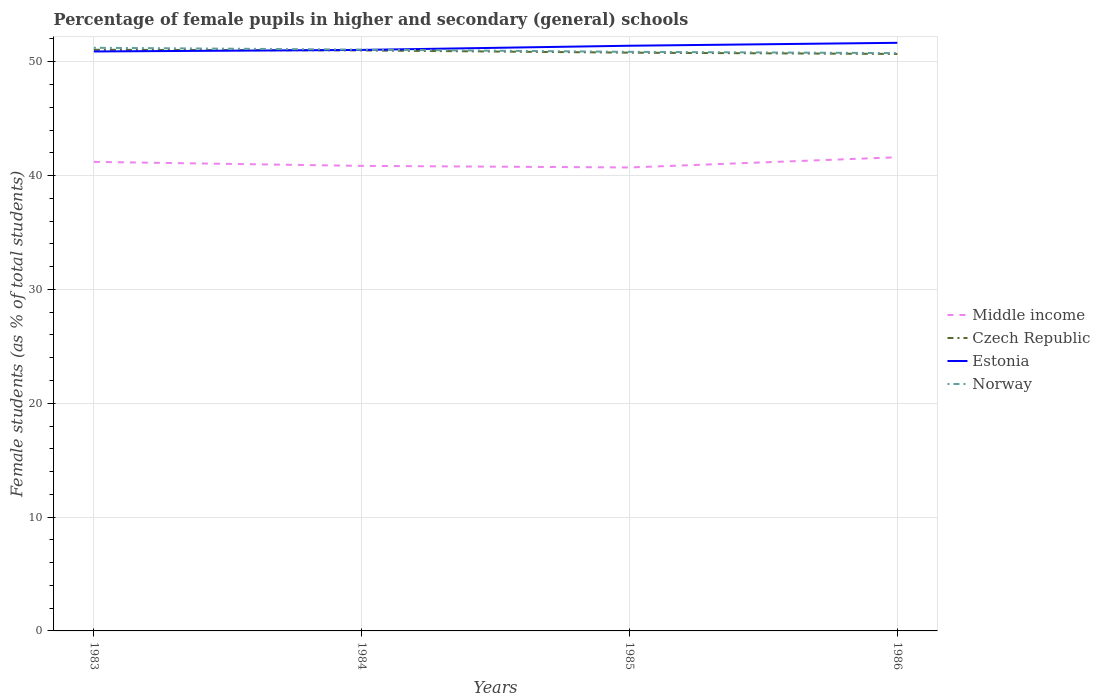How many different coloured lines are there?
Your answer should be compact. 4. Is the number of lines equal to the number of legend labels?
Ensure brevity in your answer.  Yes. Across all years, what is the maximum percentage of female pupils in higher and secondary schools in Estonia?
Ensure brevity in your answer.  50.9. In which year was the percentage of female pupils in higher and secondary schools in Estonia maximum?
Offer a very short reply. 1983. What is the total percentage of female pupils in higher and secondary schools in Norway in the graph?
Make the answer very short. 0.47. What is the difference between the highest and the second highest percentage of female pupils in higher and secondary schools in Norway?
Your answer should be very brief. 0.47. What is the difference between the highest and the lowest percentage of female pupils in higher and secondary schools in Norway?
Keep it short and to the point. 2. Is the percentage of female pupils in higher and secondary schools in Estonia strictly greater than the percentage of female pupils in higher and secondary schools in Norway over the years?
Offer a terse response. No. What is the difference between two consecutive major ticks on the Y-axis?
Make the answer very short. 10. Does the graph contain any zero values?
Your answer should be compact. No. Does the graph contain grids?
Give a very brief answer. Yes. What is the title of the graph?
Your answer should be compact. Percentage of female pupils in higher and secondary (general) schools. Does "Mongolia" appear as one of the legend labels in the graph?
Ensure brevity in your answer.  No. What is the label or title of the Y-axis?
Give a very brief answer. Female students (as % of total students). What is the Female students (as % of total students) in Middle income in 1983?
Make the answer very short. 41.2. What is the Female students (as % of total students) in Czech Republic in 1983?
Make the answer very short. 51.05. What is the Female students (as % of total students) in Estonia in 1983?
Make the answer very short. 50.9. What is the Female students (as % of total students) in Norway in 1983?
Provide a short and direct response. 51.23. What is the Female students (as % of total students) of Middle income in 1984?
Provide a short and direct response. 40.85. What is the Female students (as % of total students) in Czech Republic in 1984?
Offer a very short reply. 51. What is the Female students (as % of total students) of Estonia in 1984?
Give a very brief answer. 51.04. What is the Female students (as % of total students) of Norway in 1984?
Provide a short and direct response. 51.07. What is the Female students (as % of total students) of Middle income in 1985?
Keep it short and to the point. 40.71. What is the Female students (as % of total students) in Czech Republic in 1985?
Your response must be concise. 50.8. What is the Female students (as % of total students) in Estonia in 1985?
Offer a terse response. 51.41. What is the Female students (as % of total students) in Norway in 1985?
Provide a short and direct response. 50.87. What is the Female students (as % of total students) of Middle income in 1986?
Make the answer very short. 41.61. What is the Female students (as % of total students) of Czech Republic in 1986?
Your answer should be very brief. 50.69. What is the Female students (as % of total students) in Estonia in 1986?
Your answer should be very brief. 51.67. What is the Female students (as % of total students) in Norway in 1986?
Your answer should be compact. 50.76. Across all years, what is the maximum Female students (as % of total students) in Middle income?
Ensure brevity in your answer.  41.61. Across all years, what is the maximum Female students (as % of total students) of Czech Republic?
Offer a very short reply. 51.05. Across all years, what is the maximum Female students (as % of total students) of Estonia?
Your answer should be very brief. 51.67. Across all years, what is the maximum Female students (as % of total students) of Norway?
Give a very brief answer. 51.23. Across all years, what is the minimum Female students (as % of total students) of Middle income?
Offer a very short reply. 40.71. Across all years, what is the minimum Female students (as % of total students) in Czech Republic?
Provide a short and direct response. 50.69. Across all years, what is the minimum Female students (as % of total students) of Estonia?
Offer a terse response. 50.9. Across all years, what is the minimum Female students (as % of total students) in Norway?
Offer a terse response. 50.76. What is the total Female students (as % of total students) in Middle income in the graph?
Keep it short and to the point. 164.38. What is the total Female students (as % of total students) in Czech Republic in the graph?
Provide a succinct answer. 203.53. What is the total Female students (as % of total students) in Estonia in the graph?
Your response must be concise. 205.02. What is the total Female students (as % of total students) in Norway in the graph?
Your answer should be compact. 203.93. What is the difference between the Female students (as % of total students) of Middle income in 1983 and that in 1984?
Your response must be concise. 0.35. What is the difference between the Female students (as % of total students) in Czech Republic in 1983 and that in 1984?
Ensure brevity in your answer.  0.06. What is the difference between the Female students (as % of total students) of Estonia in 1983 and that in 1984?
Offer a very short reply. -0.14. What is the difference between the Female students (as % of total students) in Norway in 1983 and that in 1984?
Offer a terse response. 0.16. What is the difference between the Female students (as % of total students) of Middle income in 1983 and that in 1985?
Offer a very short reply. 0.49. What is the difference between the Female students (as % of total students) in Czech Republic in 1983 and that in 1985?
Your answer should be very brief. 0.25. What is the difference between the Female students (as % of total students) of Estonia in 1983 and that in 1985?
Keep it short and to the point. -0.5. What is the difference between the Female students (as % of total students) in Norway in 1983 and that in 1985?
Provide a short and direct response. 0.36. What is the difference between the Female students (as % of total students) of Middle income in 1983 and that in 1986?
Your response must be concise. -0.41. What is the difference between the Female students (as % of total students) in Czech Republic in 1983 and that in 1986?
Provide a short and direct response. 0.37. What is the difference between the Female students (as % of total students) of Estonia in 1983 and that in 1986?
Offer a terse response. -0.76. What is the difference between the Female students (as % of total students) of Norway in 1983 and that in 1986?
Your answer should be compact. 0.47. What is the difference between the Female students (as % of total students) in Middle income in 1984 and that in 1985?
Offer a terse response. 0.14. What is the difference between the Female students (as % of total students) of Czech Republic in 1984 and that in 1985?
Give a very brief answer. 0.2. What is the difference between the Female students (as % of total students) of Estonia in 1984 and that in 1985?
Your answer should be very brief. -0.37. What is the difference between the Female students (as % of total students) of Norway in 1984 and that in 1985?
Give a very brief answer. 0.2. What is the difference between the Female students (as % of total students) in Middle income in 1984 and that in 1986?
Offer a very short reply. -0.76. What is the difference between the Female students (as % of total students) in Czech Republic in 1984 and that in 1986?
Your response must be concise. 0.31. What is the difference between the Female students (as % of total students) of Estonia in 1984 and that in 1986?
Keep it short and to the point. -0.62. What is the difference between the Female students (as % of total students) of Norway in 1984 and that in 1986?
Provide a short and direct response. 0.31. What is the difference between the Female students (as % of total students) in Middle income in 1985 and that in 1986?
Provide a short and direct response. -0.9. What is the difference between the Female students (as % of total students) of Czech Republic in 1985 and that in 1986?
Provide a short and direct response. 0.11. What is the difference between the Female students (as % of total students) of Estonia in 1985 and that in 1986?
Offer a very short reply. -0.26. What is the difference between the Female students (as % of total students) in Norway in 1985 and that in 1986?
Give a very brief answer. 0.11. What is the difference between the Female students (as % of total students) in Middle income in 1983 and the Female students (as % of total students) in Czech Republic in 1984?
Keep it short and to the point. -9.79. What is the difference between the Female students (as % of total students) of Middle income in 1983 and the Female students (as % of total students) of Estonia in 1984?
Ensure brevity in your answer.  -9.84. What is the difference between the Female students (as % of total students) of Middle income in 1983 and the Female students (as % of total students) of Norway in 1984?
Provide a succinct answer. -9.86. What is the difference between the Female students (as % of total students) in Czech Republic in 1983 and the Female students (as % of total students) in Estonia in 1984?
Your answer should be compact. 0.01. What is the difference between the Female students (as % of total students) in Czech Republic in 1983 and the Female students (as % of total students) in Norway in 1984?
Your answer should be compact. -0.02. What is the difference between the Female students (as % of total students) of Estonia in 1983 and the Female students (as % of total students) of Norway in 1984?
Offer a very short reply. -0.16. What is the difference between the Female students (as % of total students) of Middle income in 1983 and the Female students (as % of total students) of Czech Republic in 1985?
Provide a succinct answer. -9.59. What is the difference between the Female students (as % of total students) in Middle income in 1983 and the Female students (as % of total students) in Estonia in 1985?
Keep it short and to the point. -10.2. What is the difference between the Female students (as % of total students) of Middle income in 1983 and the Female students (as % of total students) of Norway in 1985?
Make the answer very short. -9.67. What is the difference between the Female students (as % of total students) of Czech Republic in 1983 and the Female students (as % of total students) of Estonia in 1985?
Provide a succinct answer. -0.36. What is the difference between the Female students (as % of total students) in Czech Republic in 1983 and the Female students (as % of total students) in Norway in 1985?
Your response must be concise. 0.18. What is the difference between the Female students (as % of total students) in Estonia in 1983 and the Female students (as % of total students) in Norway in 1985?
Make the answer very short. 0.03. What is the difference between the Female students (as % of total students) of Middle income in 1983 and the Female students (as % of total students) of Czech Republic in 1986?
Offer a terse response. -9.48. What is the difference between the Female students (as % of total students) in Middle income in 1983 and the Female students (as % of total students) in Estonia in 1986?
Give a very brief answer. -10.46. What is the difference between the Female students (as % of total students) in Middle income in 1983 and the Female students (as % of total students) in Norway in 1986?
Make the answer very short. -9.56. What is the difference between the Female students (as % of total students) of Czech Republic in 1983 and the Female students (as % of total students) of Estonia in 1986?
Provide a short and direct response. -0.61. What is the difference between the Female students (as % of total students) in Czech Republic in 1983 and the Female students (as % of total students) in Norway in 1986?
Offer a terse response. 0.29. What is the difference between the Female students (as % of total students) in Estonia in 1983 and the Female students (as % of total students) in Norway in 1986?
Your response must be concise. 0.14. What is the difference between the Female students (as % of total students) of Middle income in 1984 and the Female students (as % of total students) of Czech Republic in 1985?
Provide a succinct answer. -9.95. What is the difference between the Female students (as % of total students) of Middle income in 1984 and the Female students (as % of total students) of Estonia in 1985?
Your answer should be compact. -10.55. What is the difference between the Female students (as % of total students) in Middle income in 1984 and the Female students (as % of total students) in Norway in 1985?
Ensure brevity in your answer.  -10.02. What is the difference between the Female students (as % of total students) in Czech Republic in 1984 and the Female students (as % of total students) in Estonia in 1985?
Your answer should be compact. -0.41. What is the difference between the Female students (as % of total students) of Czech Republic in 1984 and the Female students (as % of total students) of Norway in 1985?
Ensure brevity in your answer.  0.12. What is the difference between the Female students (as % of total students) of Estonia in 1984 and the Female students (as % of total students) of Norway in 1985?
Your response must be concise. 0.17. What is the difference between the Female students (as % of total students) in Middle income in 1984 and the Female students (as % of total students) in Czech Republic in 1986?
Your answer should be very brief. -9.83. What is the difference between the Female students (as % of total students) of Middle income in 1984 and the Female students (as % of total students) of Estonia in 1986?
Keep it short and to the point. -10.81. What is the difference between the Female students (as % of total students) in Middle income in 1984 and the Female students (as % of total students) in Norway in 1986?
Provide a succinct answer. -9.91. What is the difference between the Female students (as % of total students) of Czech Republic in 1984 and the Female students (as % of total students) of Estonia in 1986?
Make the answer very short. -0.67. What is the difference between the Female students (as % of total students) in Czech Republic in 1984 and the Female students (as % of total students) in Norway in 1986?
Give a very brief answer. 0.23. What is the difference between the Female students (as % of total students) of Estonia in 1984 and the Female students (as % of total students) of Norway in 1986?
Ensure brevity in your answer.  0.28. What is the difference between the Female students (as % of total students) in Middle income in 1985 and the Female students (as % of total students) in Czech Republic in 1986?
Give a very brief answer. -9.97. What is the difference between the Female students (as % of total students) in Middle income in 1985 and the Female students (as % of total students) in Estonia in 1986?
Make the answer very short. -10.95. What is the difference between the Female students (as % of total students) in Middle income in 1985 and the Female students (as % of total students) in Norway in 1986?
Keep it short and to the point. -10.05. What is the difference between the Female students (as % of total students) in Czech Republic in 1985 and the Female students (as % of total students) in Estonia in 1986?
Offer a terse response. -0.87. What is the difference between the Female students (as % of total students) in Czech Republic in 1985 and the Female students (as % of total students) in Norway in 1986?
Offer a very short reply. 0.04. What is the difference between the Female students (as % of total students) of Estonia in 1985 and the Female students (as % of total students) of Norway in 1986?
Your response must be concise. 0.65. What is the average Female students (as % of total students) of Middle income per year?
Your response must be concise. 41.1. What is the average Female students (as % of total students) in Czech Republic per year?
Provide a short and direct response. 50.88. What is the average Female students (as % of total students) in Estonia per year?
Your answer should be very brief. 51.25. What is the average Female students (as % of total students) of Norway per year?
Give a very brief answer. 50.98. In the year 1983, what is the difference between the Female students (as % of total students) of Middle income and Female students (as % of total students) of Czech Republic?
Offer a terse response. -9.85. In the year 1983, what is the difference between the Female students (as % of total students) of Middle income and Female students (as % of total students) of Estonia?
Ensure brevity in your answer.  -9.7. In the year 1983, what is the difference between the Female students (as % of total students) in Middle income and Female students (as % of total students) in Norway?
Offer a very short reply. -10.02. In the year 1983, what is the difference between the Female students (as % of total students) in Czech Republic and Female students (as % of total students) in Estonia?
Keep it short and to the point. 0.15. In the year 1983, what is the difference between the Female students (as % of total students) of Czech Republic and Female students (as % of total students) of Norway?
Provide a succinct answer. -0.18. In the year 1983, what is the difference between the Female students (as % of total students) in Estonia and Female students (as % of total students) in Norway?
Your answer should be compact. -0.32. In the year 1984, what is the difference between the Female students (as % of total students) of Middle income and Female students (as % of total students) of Czech Republic?
Provide a succinct answer. -10.14. In the year 1984, what is the difference between the Female students (as % of total students) in Middle income and Female students (as % of total students) in Estonia?
Your answer should be very brief. -10.19. In the year 1984, what is the difference between the Female students (as % of total students) of Middle income and Female students (as % of total students) of Norway?
Make the answer very short. -10.21. In the year 1984, what is the difference between the Female students (as % of total students) in Czech Republic and Female students (as % of total students) in Estonia?
Make the answer very short. -0.04. In the year 1984, what is the difference between the Female students (as % of total students) of Czech Republic and Female students (as % of total students) of Norway?
Your answer should be very brief. -0.07. In the year 1984, what is the difference between the Female students (as % of total students) in Estonia and Female students (as % of total students) in Norway?
Give a very brief answer. -0.03. In the year 1985, what is the difference between the Female students (as % of total students) of Middle income and Female students (as % of total students) of Czech Republic?
Provide a succinct answer. -10.09. In the year 1985, what is the difference between the Female students (as % of total students) in Middle income and Female students (as % of total students) in Estonia?
Provide a short and direct response. -10.69. In the year 1985, what is the difference between the Female students (as % of total students) in Middle income and Female students (as % of total students) in Norway?
Your answer should be very brief. -10.16. In the year 1985, what is the difference between the Female students (as % of total students) in Czech Republic and Female students (as % of total students) in Estonia?
Your response must be concise. -0.61. In the year 1985, what is the difference between the Female students (as % of total students) of Czech Republic and Female students (as % of total students) of Norway?
Give a very brief answer. -0.07. In the year 1985, what is the difference between the Female students (as % of total students) of Estonia and Female students (as % of total students) of Norway?
Ensure brevity in your answer.  0.54. In the year 1986, what is the difference between the Female students (as % of total students) of Middle income and Female students (as % of total students) of Czech Republic?
Your answer should be very brief. -9.07. In the year 1986, what is the difference between the Female students (as % of total students) of Middle income and Female students (as % of total students) of Estonia?
Your response must be concise. -10.05. In the year 1986, what is the difference between the Female students (as % of total students) of Middle income and Female students (as % of total students) of Norway?
Offer a terse response. -9.15. In the year 1986, what is the difference between the Female students (as % of total students) in Czech Republic and Female students (as % of total students) in Estonia?
Provide a succinct answer. -0.98. In the year 1986, what is the difference between the Female students (as % of total students) of Czech Republic and Female students (as % of total students) of Norway?
Provide a succinct answer. -0.08. In the year 1986, what is the difference between the Female students (as % of total students) of Estonia and Female students (as % of total students) of Norway?
Your answer should be very brief. 0.9. What is the ratio of the Female students (as % of total students) of Middle income in 1983 to that in 1984?
Your response must be concise. 1.01. What is the ratio of the Female students (as % of total students) of Czech Republic in 1983 to that in 1984?
Provide a succinct answer. 1. What is the ratio of the Female students (as % of total students) of Estonia in 1983 to that in 1984?
Make the answer very short. 1. What is the ratio of the Female students (as % of total students) of Norway in 1983 to that in 1984?
Your answer should be very brief. 1. What is the ratio of the Female students (as % of total students) of Middle income in 1983 to that in 1985?
Give a very brief answer. 1.01. What is the ratio of the Female students (as % of total students) of Czech Republic in 1983 to that in 1985?
Your answer should be very brief. 1. What is the ratio of the Female students (as % of total students) in Estonia in 1983 to that in 1985?
Make the answer very short. 0.99. What is the ratio of the Female students (as % of total students) of Norway in 1983 to that in 1985?
Your answer should be compact. 1.01. What is the ratio of the Female students (as % of total students) of Middle income in 1983 to that in 1986?
Your answer should be compact. 0.99. What is the ratio of the Female students (as % of total students) in Norway in 1983 to that in 1986?
Ensure brevity in your answer.  1.01. What is the ratio of the Female students (as % of total students) in Czech Republic in 1984 to that in 1985?
Provide a succinct answer. 1. What is the ratio of the Female students (as % of total students) of Estonia in 1984 to that in 1985?
Your answer should be compact. 0.99. What is the ratio of the Female students (as % of total students) of Norway in 1984 to that in 1985?
Provide a succinct answer. 1. What is the ratio of the Female students (as % of total students) in Middle income in 1984 to that in 1986?
Provide a succinct answer. 0.98. What is the ratio of the Female students (as % of total students) in Czech Republic in 1984 to that in 1986?
Offer a terse response. 1.01. What is the ratio of the Female students (as % of total students) in Estonia in 1984 to that in 1986?
Provide a short and direct response. 0.99. What is the ratio of the Female students (as % of total students) of Middle income in 1985 to that in 1986?
Your answer should be compact. 0.98. What is the ratio of the Female students (as % of total students) in Norway in 1985 to that in 1986?
Provide a short and direct response. 1. What is the difference between the highest and the second highest Female students (as % of total students) in Middle income?
Provide a short and direct response. 0.41. What is the difference between the highest and the second highest Female students (as % of total students) of Czech Republic?
Your response must be concise. 0.06. What is the difference between the highest and the second highest Female students (as % of total students) in Estonia?
Your response must be concise. 0.26. What is the difference between the highest and the second highest Female students (as % of total students) in Norway?
Your response must be concise. 0.16. What is the difference between the highest and the lowest Female students (as % of total students) in Middle income?
Keep it short and to the point. 0.9. What is the difference between the highest and the lowest Female students (as % of total students) in Czech Republic?
Offer a very short reply. 0.37. What is the difference between the highest and the lowest Female students (as % of total students) of Estonia?
Provide a short and direct response. 0.76. What is the difference between the highest and the lowest Female students (as % of total students) in Norway?
Keep it short and to the point. 0.47. 